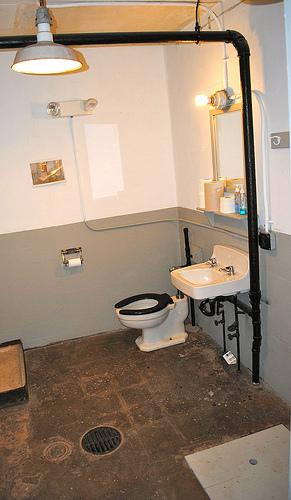In a concise manner, explain what type of room is in the image and list any significant visible items. The image displays an unfinished commercial bathroom featuring a toilet, sink, mirror, lamp, shelving, and various bathroom supplies. State the total number of toilet paper rolls visible across the image. There are four toilet paper rolls in the image. List the objects you see related to hygiene and cleanliness in the image. Toilet, sink, faucet fixtures, toilet paper rolls, toilet paper holder, pump soap dispenser, and paper towels. Identify the subject of the image, whether it is a residential or a commercial space, and mention one prominent object in the scene. The image shows an incomplete bathroom in a commercial setting, with a white and black commercial toilet as a prominent object. Describe the quality of the image. The image is of moderate quality. What kind of flooring is present in the image? Cement floor How many towels are hanging on the rack in the bathroom? There is a blue towel and a white towel hanging beside the mirror. No, it's not mentioned in the image. What type of room is depicted in the image? A bathroom What is the color of the hook on the wall? White List three objects detected in the image. Toilet with a black seat, roll of toilet paper, overhead lamp Where are the faucet fixtures located? On the sink Extract any text visible in the image. No text visible in the image Where is the mirror located in the image? Above the sink and shelf What is the color of the piping in the bathroom? Black Is there any soap left in the dispenser? Almost empty What type of toiletry items are in front of the mirror? Soap dispenser bottle, roll of brown paper towels, two toilet paper rolls Describe the contents of the image in a sentence. The image contains an incomplete bathroom with a toilet, sink, mirror, and various toiletry items. Identify any anomalies or defects in the image. A patch of dirty tiles, white paint mark on the wall Find the coordinates of the white framed mirror. X:192 Y:95 Width:73 Height:73 What is the shape of the drain on the floor? Circular shaped Which object is located at X:112 Y:292? Black toilet seat on the toilet What is the relationship between the toilet paper holder and the toilet paper roll? Toilet paper roll is mounted on the toilet paper holder Is the lamp hanging from the ceiling turned on or off? Off Count the number of toilet paper rolls on the shelf. Two 